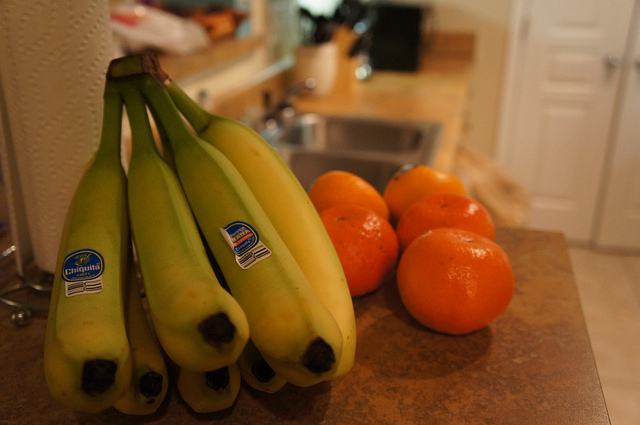How many bananas are there? There are exactly six bananas, all connected in a single bunch, looking ripe and ready to eat, with a slight green tint at the tops indicating freshness. 